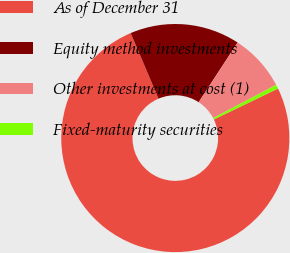<chart> <loc_0><loc_0><loc_500><loc_500><pie_chart><fcel>As of December 31<fcel>Equity method investments<fcel>Other investments at cost (1)<fcel>Fixed-maturity securities<nl><fcel>75.75%<fcel>15.6%<fcel>8.08%<fcel>0.57%<nl></chart> 